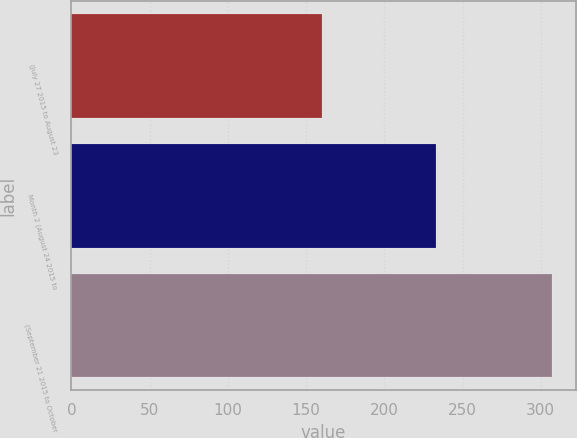Convert chart. <chart><loc_0><loc_0><loc_500><loc_500><bar_chart><fcel>(July 27 2015 to August 23<fcel>Month 2 (August 24 2015 to<fcel>(September 21 2015 to October<nl><fcel>160<fcel>233<fcel>307<nl></chart> 